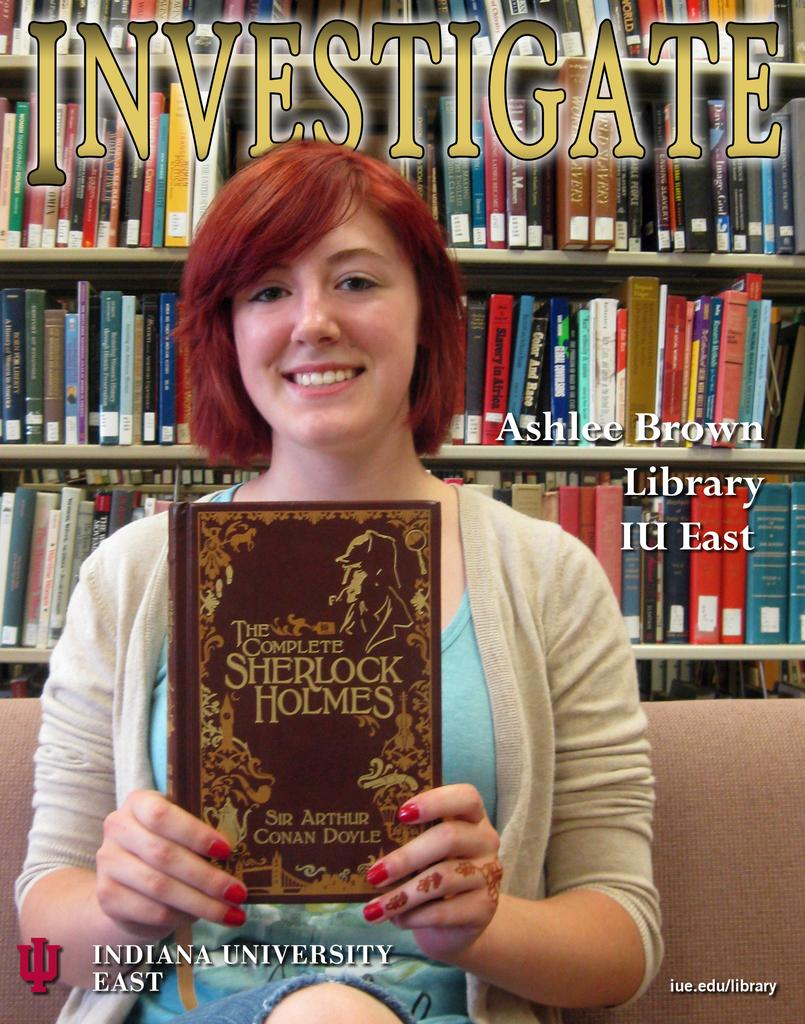<image>
Create a compact narrative representing the image presented. a book titled 'the complete sherlock holmes' on the cover of it 